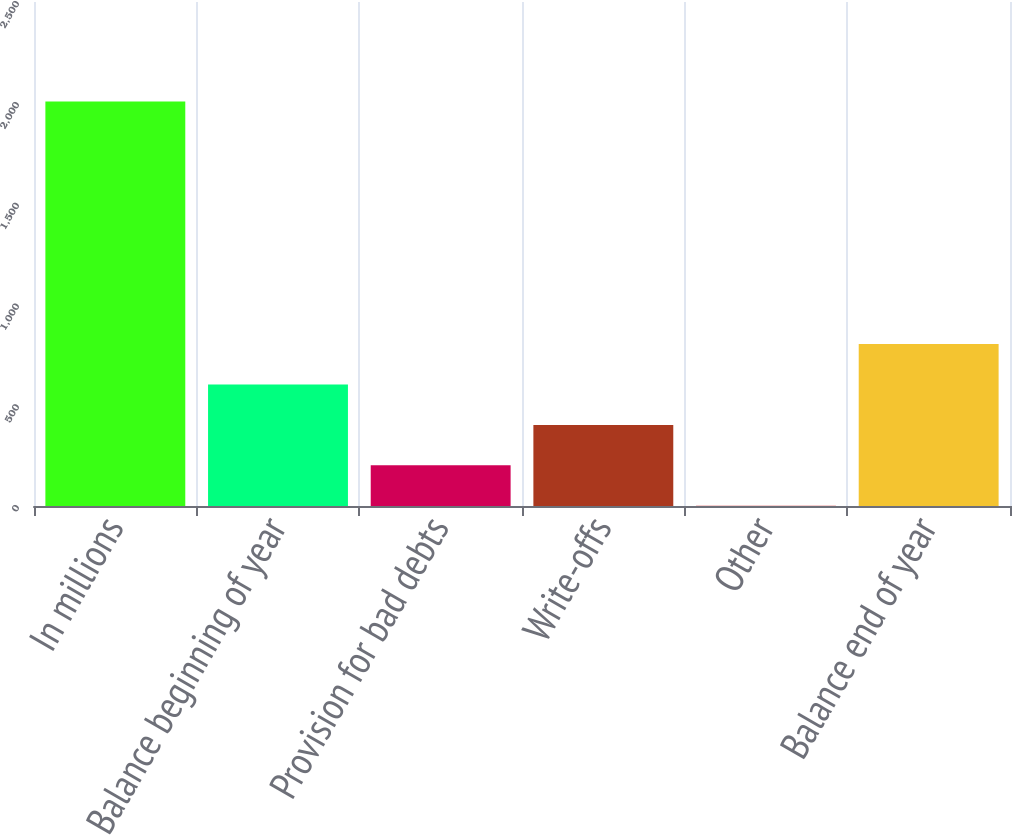<chart> <loc_0><loc_0><loc_500><loc_500><bar_chart><fcel>In millions<fcel>Balance beginning of year<fcel>Provision for bad debts<fcel>Write-offs<fcel>Other<fcel>Balance end of year<nl><fcel>2007<fcel>602.8<fcel>201.6<fcel>402.2<fcel>1<fcel>803.4<nl></chart> 